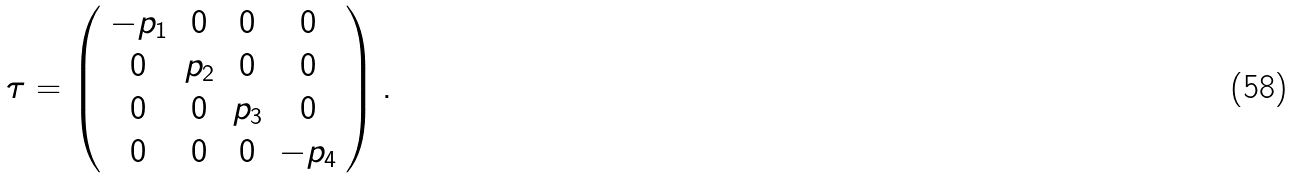Convert formula to latex. <formula><loc_0><loc_0><loc_500><loc_500>\tau = \left ( \begin{array} { c c c c } - p _ { 1 } & 0 & 0 & 0 \\ 0 & p _ { 2 } & 0 & 0 \\ 0 & 0 & p _ { 3 } & 0 \\ 0 & 0 & 0 & - p _ { 4 } \end{array} \right ) .</formula> 